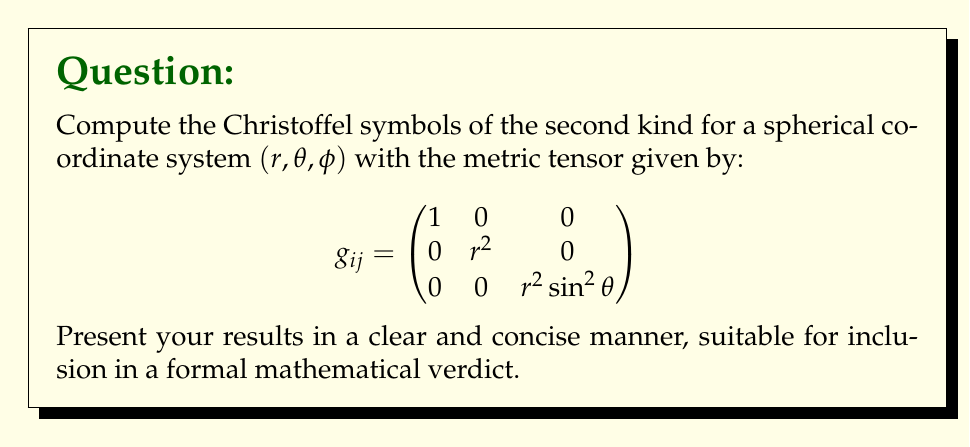Could you help me with this problem? To compute the Christoffel symbols of the second kind, we follow these steps:

1) The formula for Christoffel symbols of the second kind is:

   $$\Gamma^k_{ij} = \frac{1}{2}g^{kl}\left(\frac{\partial g_{jl}}{\partial x^i} + \frac{\partial g_{il}}{\partial x^j} - \frac{\partial g_{ij}}{\partial x^l}\right)$$

2) First, we need to calculate the inverse metric tensor $g^{ij}$:

   $$g^{ij} = \begin{pmatrix}
   1 & 0 & 0 \\
   0 & \frac{1}{r^2} & 0 \\
   0 & 0 & \frac{1}{r^2 \sin^2\theta}
   \end{pmatrix}$$

3) Now, we calculate the partial derivatives of the metric tensor components:

   $\frac{\partial g_{22}}{\partial r} = 2r$
   $\frac{\partial g_{33}}{\partial r} = 2r \sin^2\theta$
   $\frac{\partial g_{33}}{\partial \theta} = 2r^2 \sin\theta \cos\theta$

4) Using these, we can calculate the non-zero Christoffel symbols:

   $\Gamma^r_{\theta\theta} = -r$
   $\Gamma^r_{\phi\phi} = -r \sin^2\theta$
   $\Gamma^\theta_{r\theta} = \Gamma^\theta_{\theta r} = \frac{1}{r}$
   $\Gamma^\theta_{\phi\phi} = -\sin\theta \cos\theta$
   $\Gamma^\phi_{r\phi} = \Gamma^\phi_{\phi r} = \frac{1}{r}$
   $\Gamma^\phi_{\theta\phi} = \Gamma^\phi_{\phi\theta} = \cot\theta$

5) All other Christoffel symbols are zero.
Answer: $\Gamma^r_{\theta\theta} = -r$, $\Gamma^r_{\phi\phi} = -r \sin^2\theta$, $\Gamma^\theta_{r\theta} = \Gamma^\theta_{\theta r} = \frac{1}{r}$, $\Gamma^\theta_{\phi\phi} = -\sin\theta \cos\theta$, $\Gamma^\phi_{r\phi} = \Gamma^\phi_{\phi r} = \frac{1}{r}$, $\Gamma^\phi_{\theta\phi} = \Gamma^\phi_{\phi\theta} = \cot\theta$. All others are zero. 